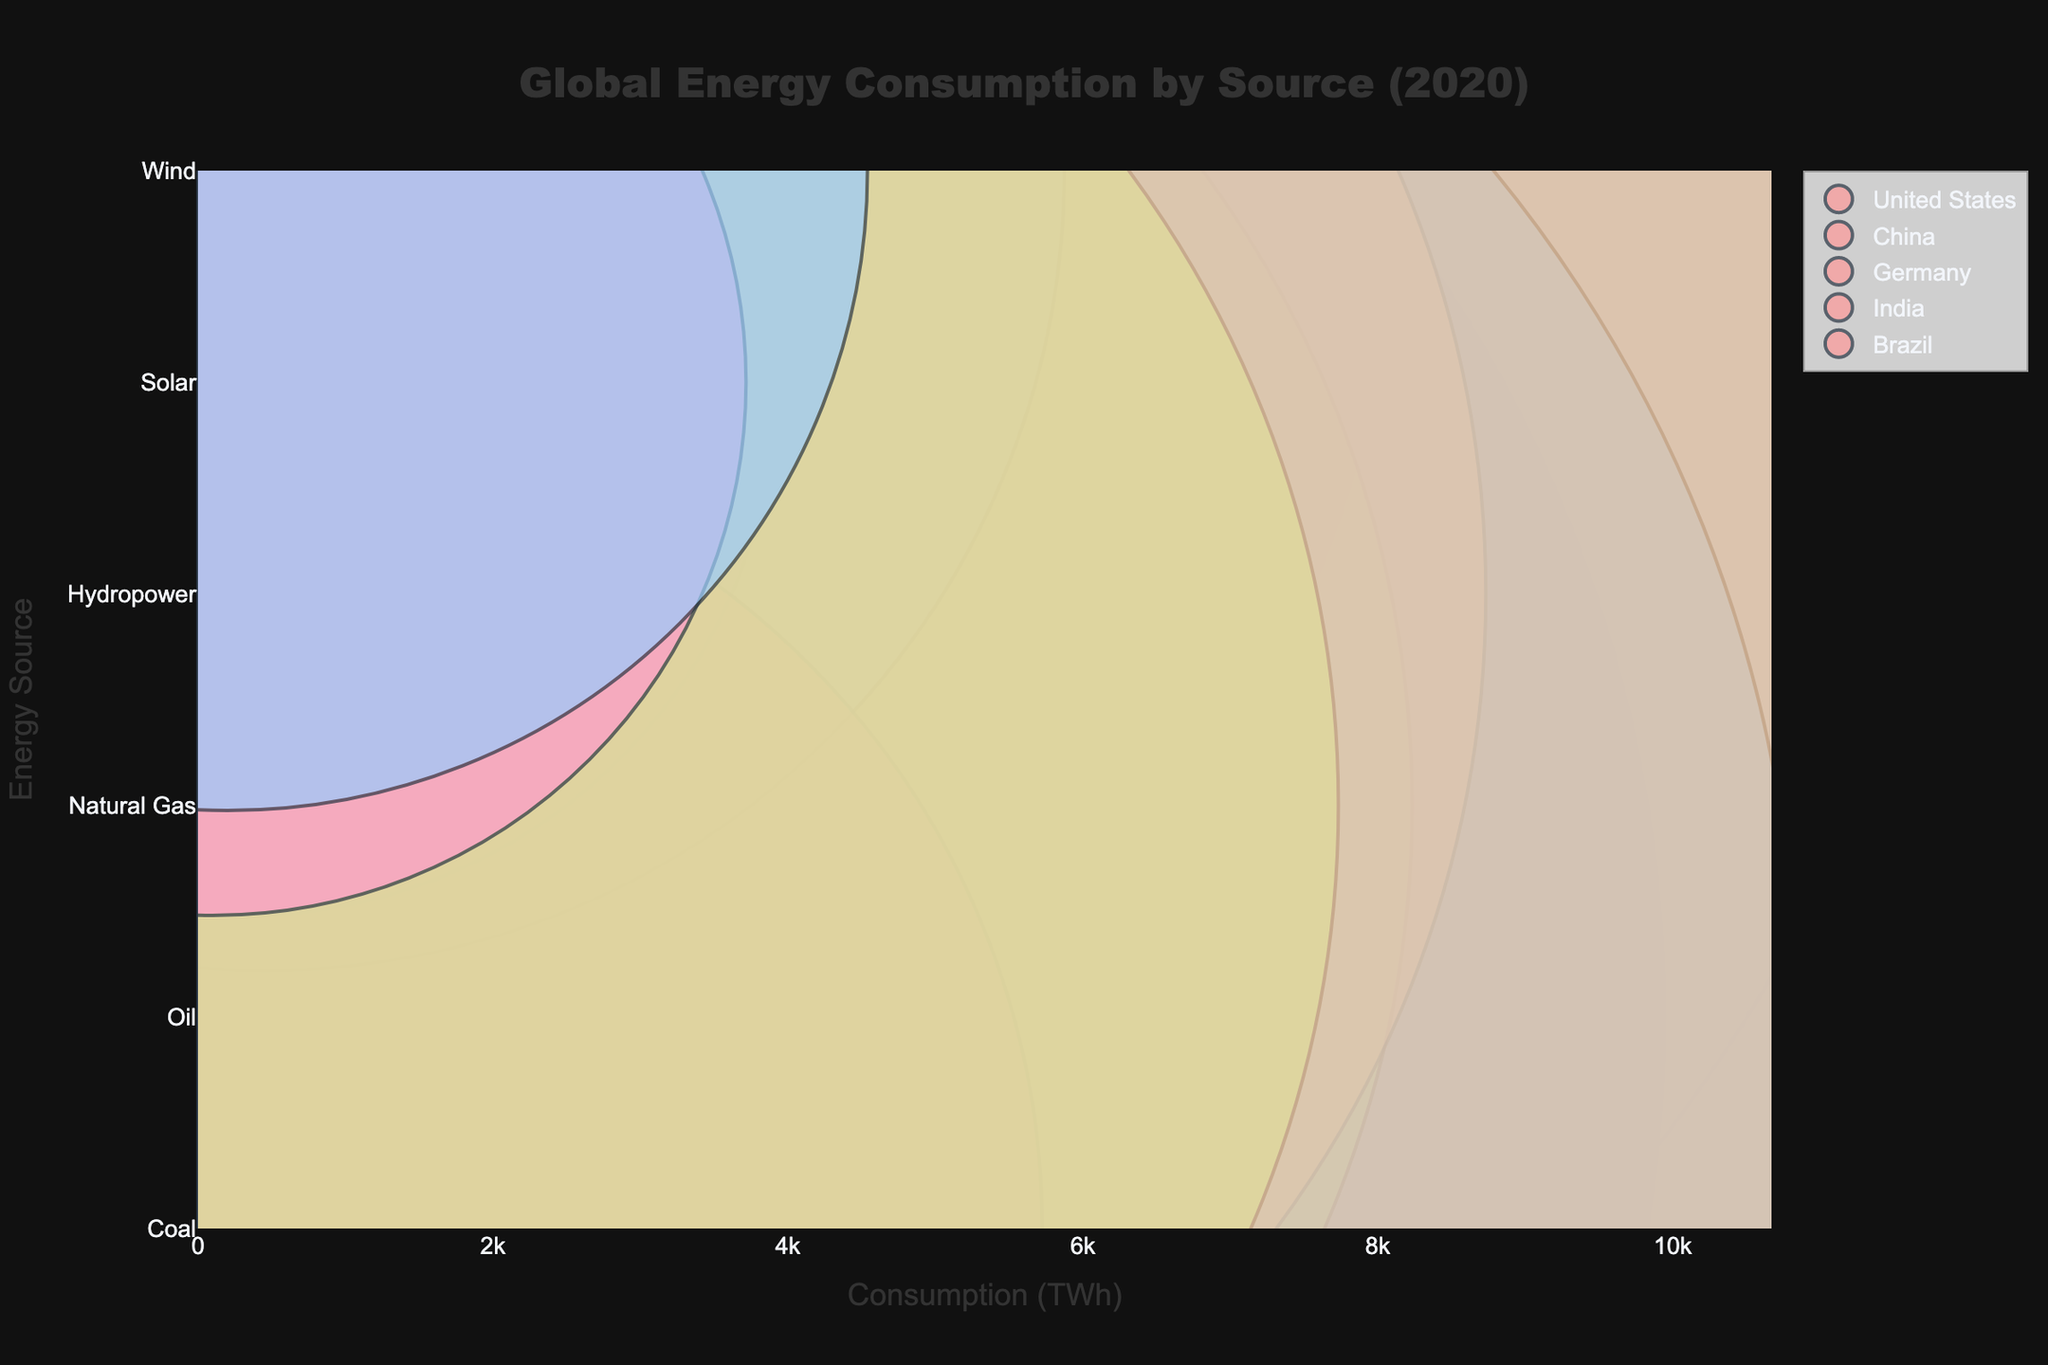What is the title of the figure? The title is usually displayed at the top of the figure, making it easy to find. In this case, the title provided in the plot command is 'Global Energy Consumption by Source (2020)', which describes the main subject of the chart.
Answer: Global Energy Consumption by Source (2020) What is the range of the x-axis in the figure? The x-axis range is typically specified in the plot layout. From the provided code, the x-axis range is set to [0, max(data['Consumption (TWh)']) * 1.1]. The maximum consumption value in the dataset is 9700 TWh, making the range [0, 9700 * 1.1].
Answer: 0 to 10670 Which country has the highest consumption of renewable energy sources? To determine this, we need to sum the consumption values of each renewable energy source for each country. The country with the highest total consumption in renewable energy sources is the answer.
Answer: United States What is the total consumption of non-renewable energy sources in China? Summing the consumption values of all non-renewable energy sources (Coal, Oil, Natural Gas) for China, the values are 8700 (Coal), 5000 (Oil), and 3000 (Natural Gas). The total is 8700 + 5000 + 3000.
Answer: 16700 TWh Which energy source has the largest bubble representing the United States? A direct visual inspection of the bubble sizes for each energy source in the United States will reveal the largest bubble. In this case, Oil has the largest bubble for the United States.
Answer: Oil Compare the consumption of Coal between the United States and India. Which country consumes more, and by how much? The consumption values for Coal in the United States and India are 4300 TWh and 6200 TWh, respectively. India consumes more Coal. The difference is 6200 - 4300.
Answer: India, 1900 TWh How many types of energy sources are represented in the figure? By inspecting the y-axis labels, we can count the distinct types of energy sources. The figure shows Coal, Oil, Natural Gas, Hydropower, Solar, and Wind.
Answer: 6 Which country has the smallest bubble for a renewable energy source, and what is the source? By inspecting the smallest bubble among the renewable energy sources, Brazil has the smallest bubble for Solar energy consumption.
Answer: Brazil, Solar What is the combined renewable energy consumption for Germany? Summing the consumption values of all renewable energy sources (Hydropower, Solar, Wind) for Germany, the values are 500 TWh (Hydropower), 500 TWh (Solar), and 900 TWh (Wind). The total is 500 + 500 + 900.
Answer: 1900 TWh 